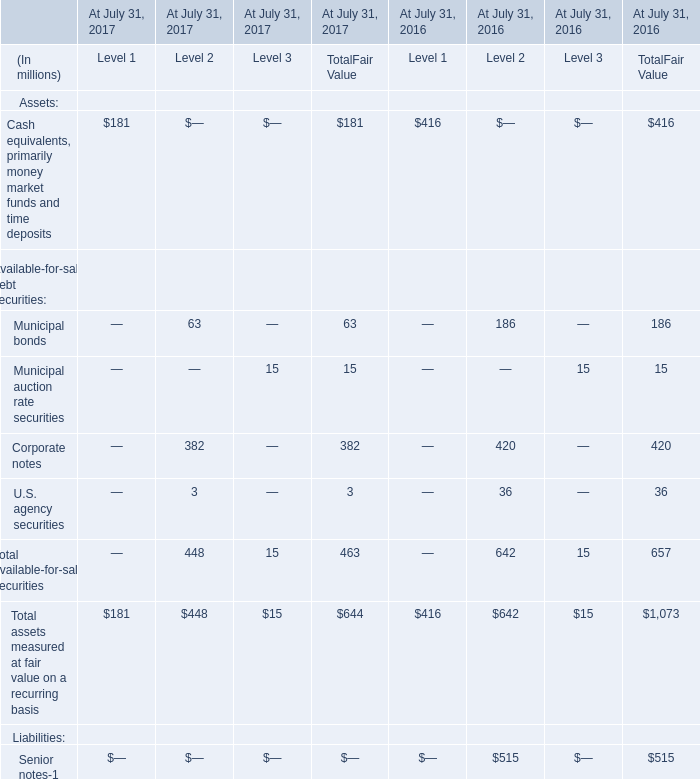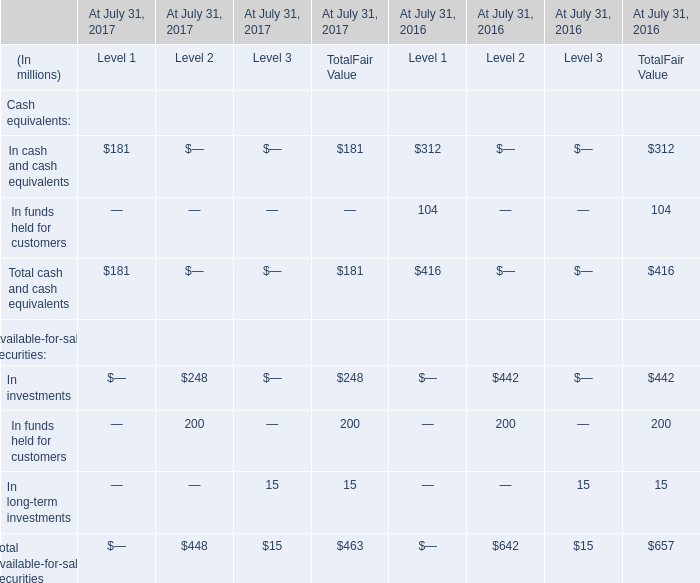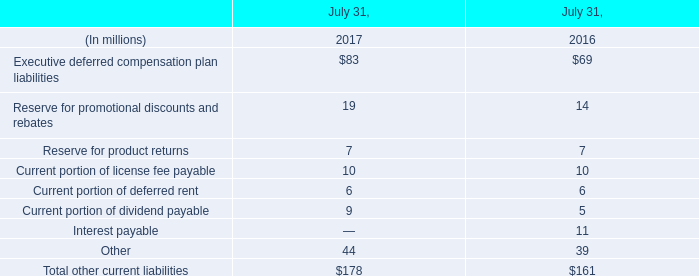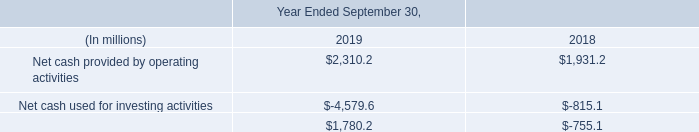What is the difference between the greatest Municipal auction rate securities in 2017 and 2016？ (in million) 
Computations: (15 - 15)
Answer: 0.0. 